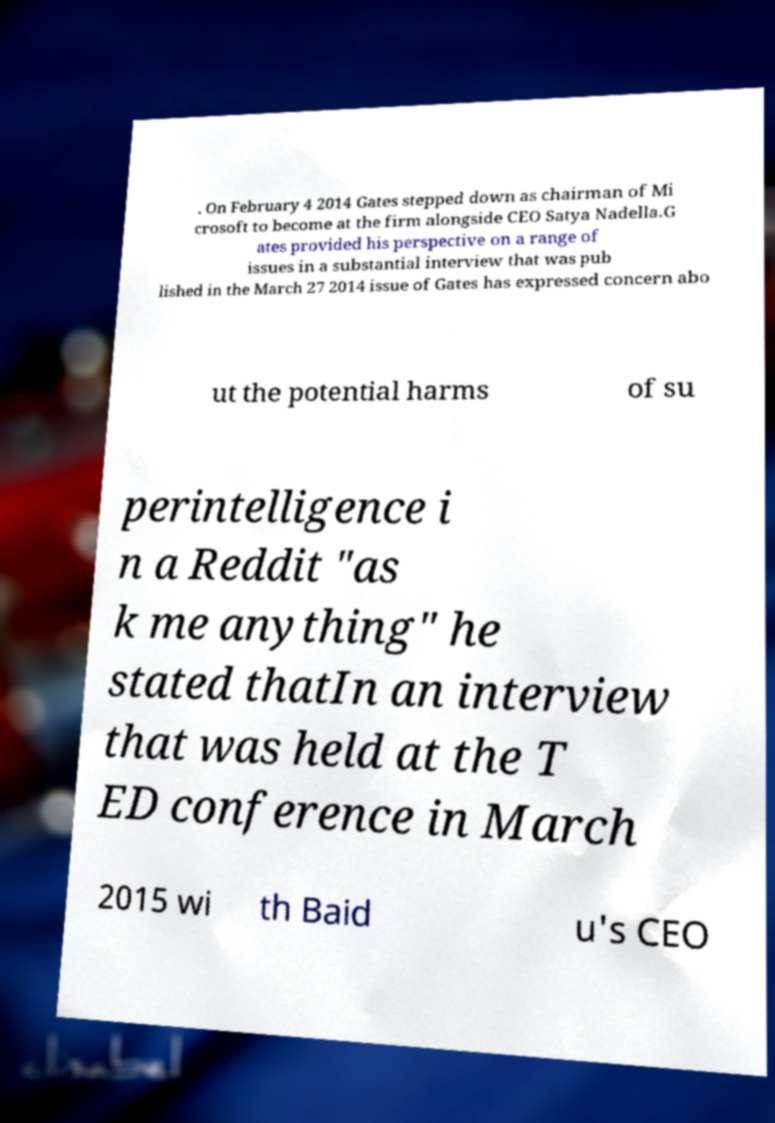Could you assist in decoding the text presented in this image and type it out clearly? . On February 4 2014 Gates stepped down as chairman of Mi crosoft to become at the firm alongside CEO Satya Nadella.G ates provided his perspective on a range of issues in a substantial interview that was pub lished in the March 27 2014 issue of Gates has expressed concern abo ut the potential harms of su perintelligence i n a Reddit "as k me anything" he stated thatIn an interview that was held at the T ED conference in March 2015 wi th Baid u's CEO 